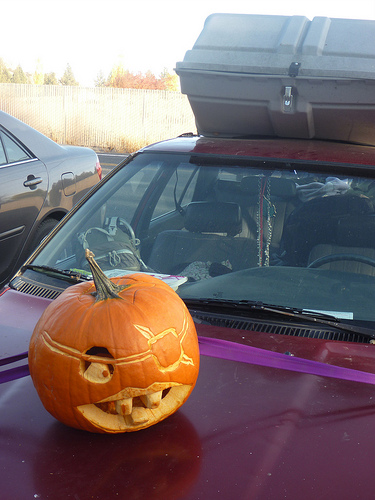<image>
Can you confirm if the car is under the wall? No. The car is not positioned under the wall. The vertical relationship between these objects is different. Is the pumpkin on the car? Yes. Looking at the image, I can see the pumpkin is positioned on top of the car, with the car providing support. 